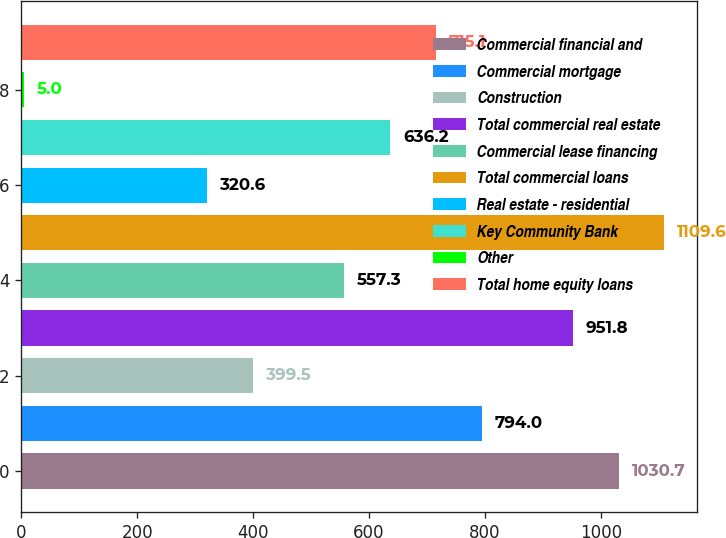Convert chart to OTSL. <chart><loc_0><loc_0><loc_500><loc_500><bar_chart><fcel>Commercial financial and<fcel>Commercial mortgage<fcel>Construction<fcel>Total commercial real estate<fcel>Commercial lease financing<fcel>Total commercial loans<fcel>Real estate - residential<fcel>Key Community Bank<fcel>Other<fcel>Total home equity loans<nl><fcel>1030.7<fcel>794<fcel>399.5<fcel>951.8<fcel>557.3<fcel>1109.6<fcel>320.6<fcel>636.2<fcel>5<fcel>715.1<nl></chart> 